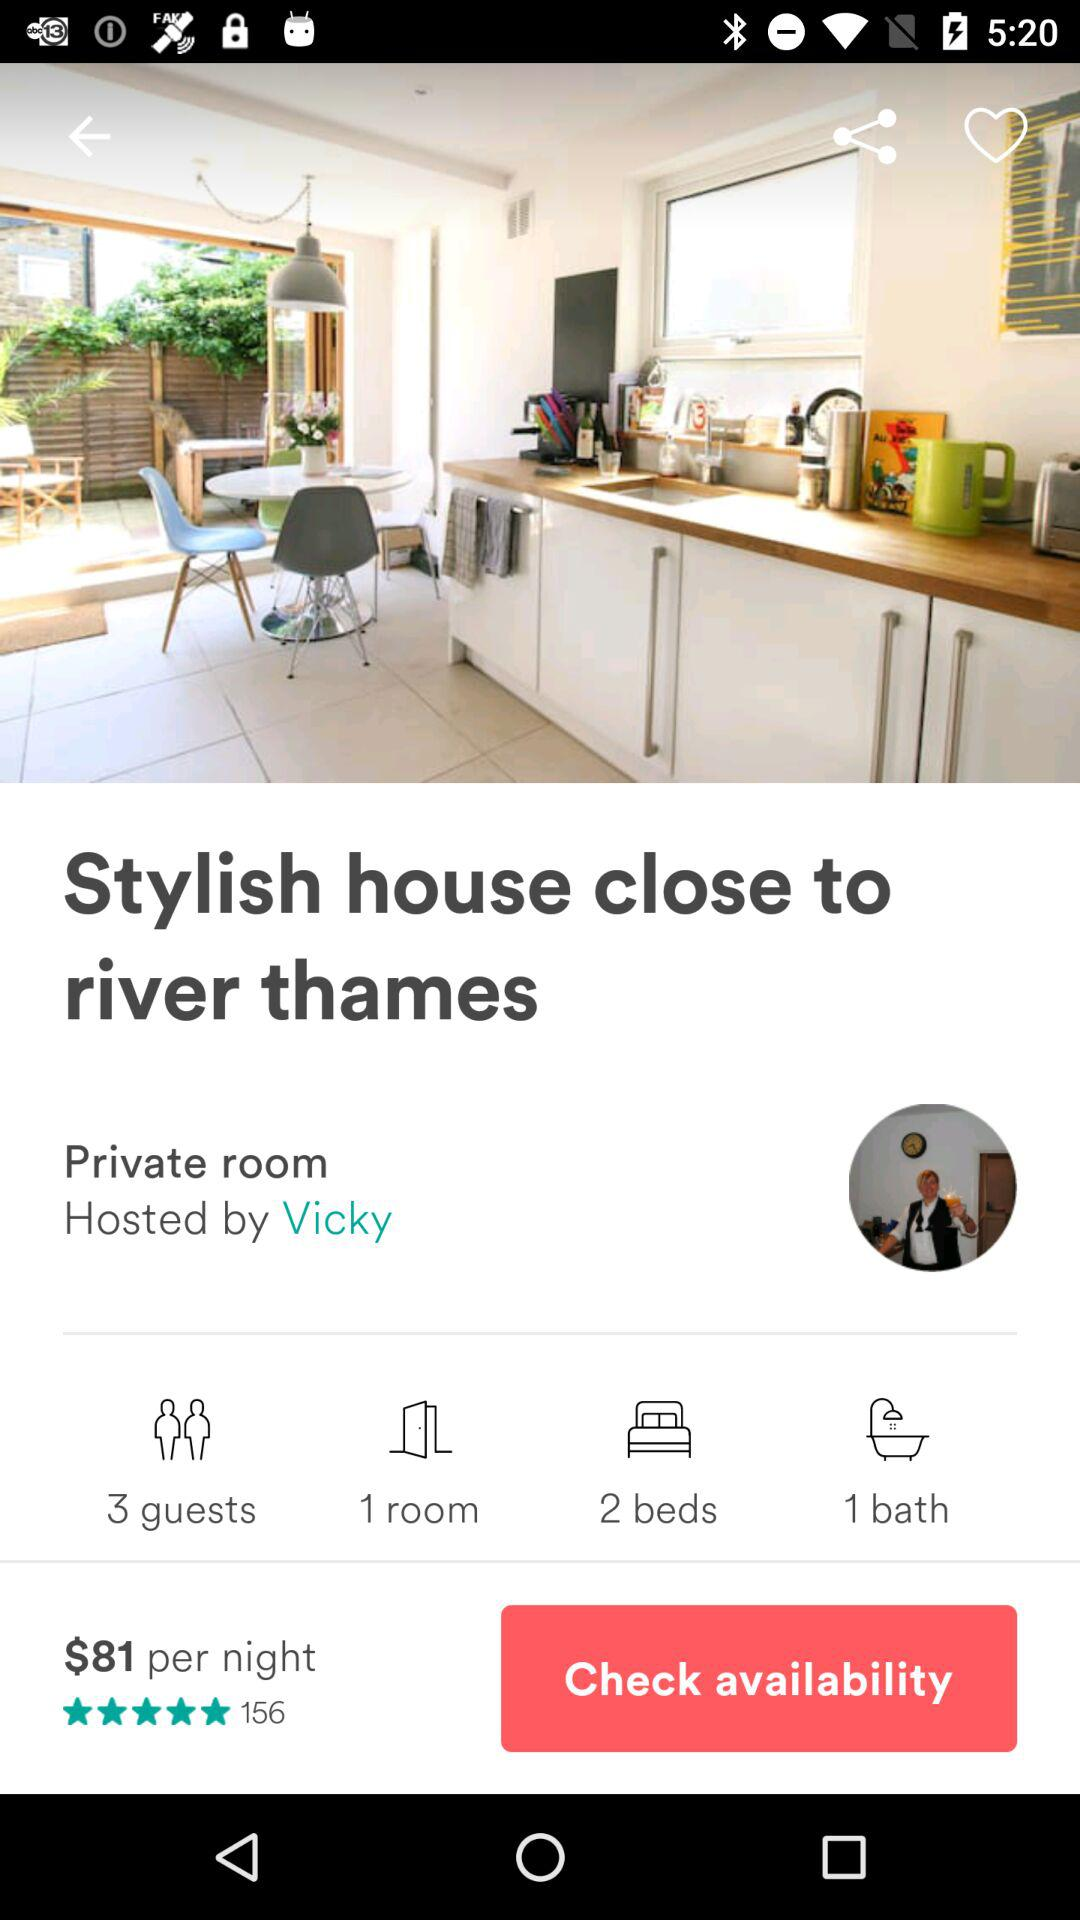What's the total count of guests? The total count of guests is 3. 